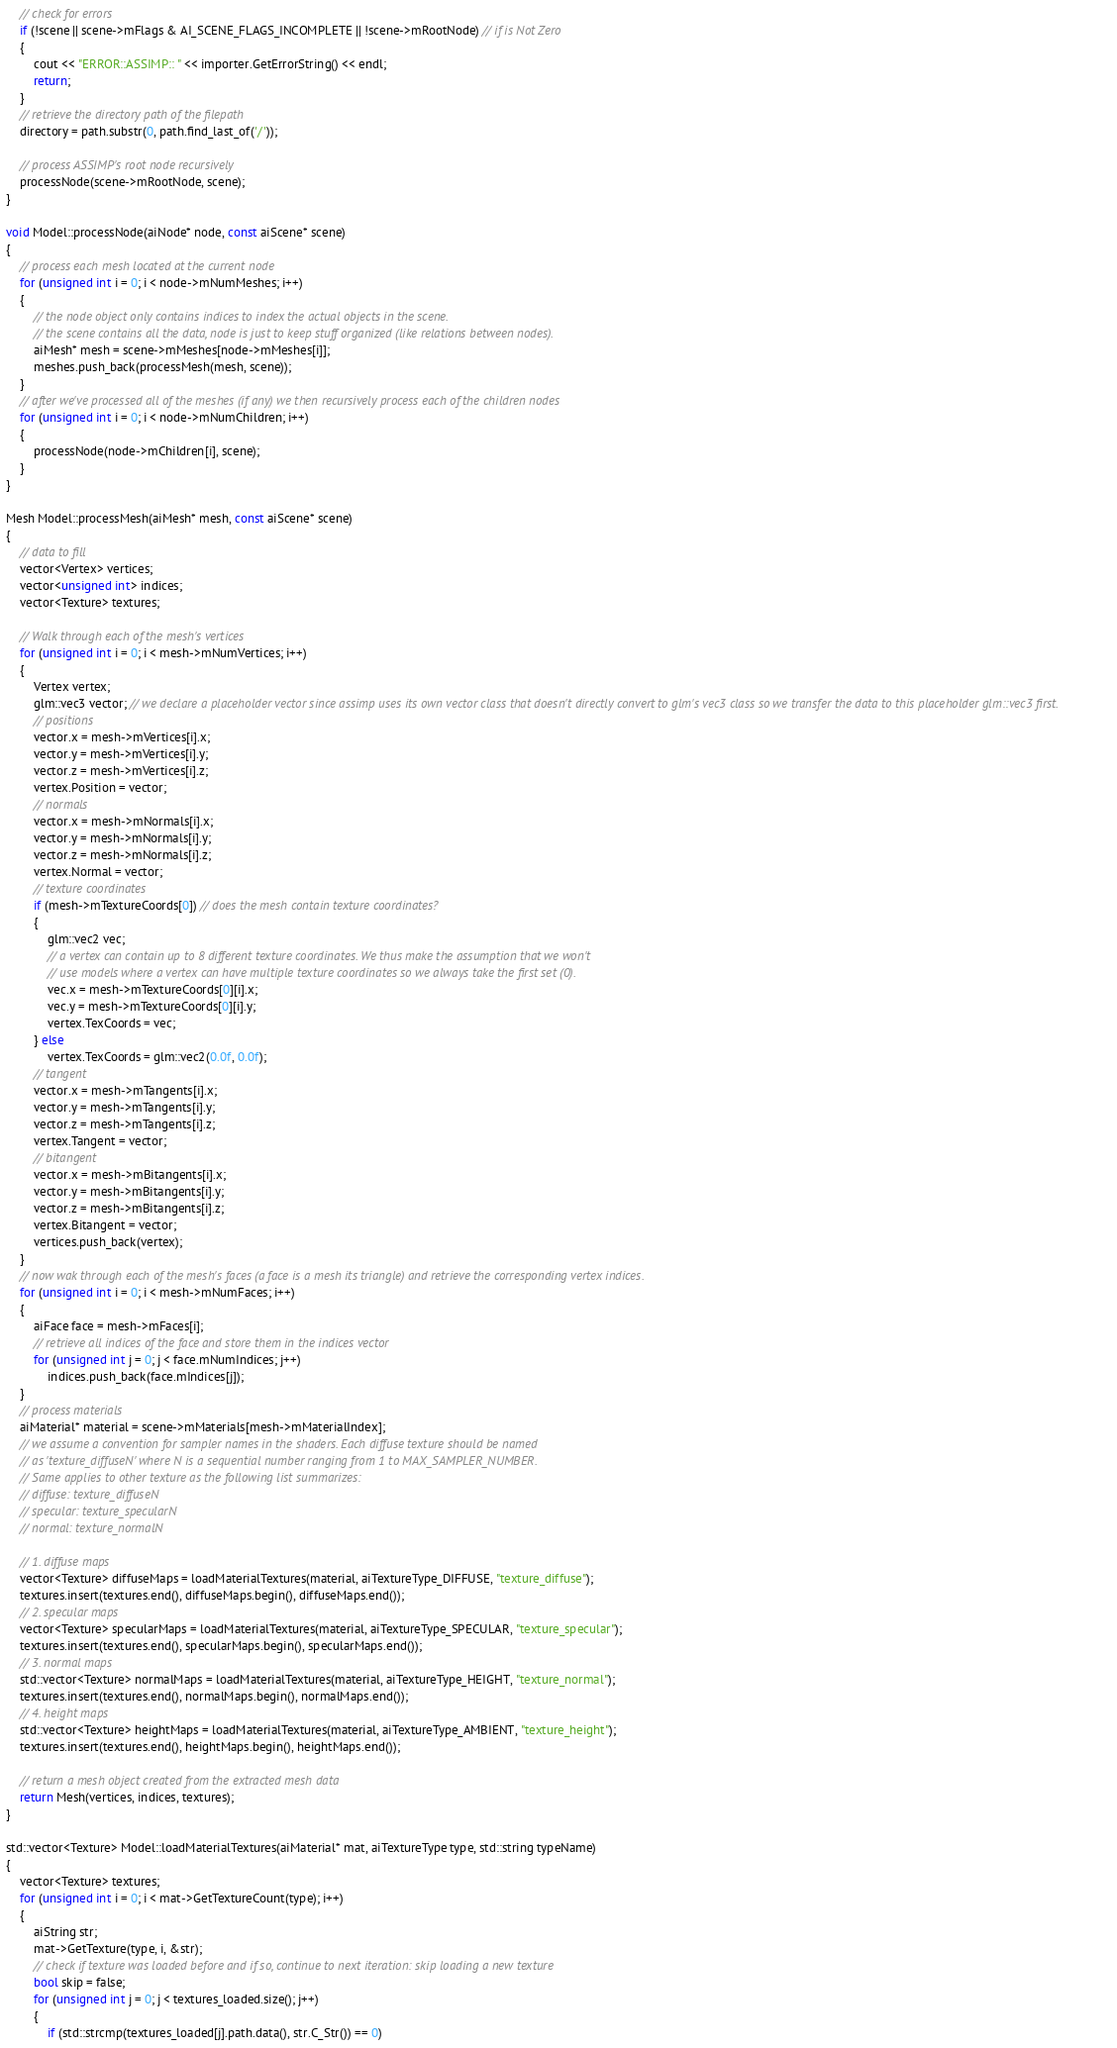<code> <loc_0><loc_0><loc_500><loc_500><_C++_>    // check for errors
    if (!scene || scene->mFlags & AI_SCENE_FLAGS_INCOMPLETE || !scene->mRootNode) // if is Not Zero
    {
        cout << "ERROR::ASSIMP:: " << importer.GetErrorString() << endl;
        return;
    }
    // retrieve the directory path of the filepath
    directory = path.substr(0, path.find_last_of('/'));

    // process ASSIMP's root node recursively
    processNode(scene->mRootNode, scene);
}

void Model::processNode(aiNode* node, const aiScene* scene)
{
    // process each mesh located at the current node
    for (unsigned int i = 0; i < node->mNumMeshes; i++)
    {
        // the node object only contains indices to index the actual objects in the scene. 
        // the scene contains all the data, node is just to keep stuff organized (like relations between nodes).
        aiMesh* mesh = scene->mMeshes[node->mMeshes[i]];
        meshes.push_back(processMesh(mesh, scene));
    }
    // after we've processed all of the meshes (if any) we then recursively process each of the children nodes
    for (unsigned int i = 0; i < node->mNumChildren; i++)
    {
        processNode(node->mChildren[i], scene);
    }
}

Mesh Model::processMesh(aiMesh* mesh, const aiScene* scene)
{
    // data to fill
    vector<Vertex> vertices;
    vector<unsigned int> indices;
    vector<Texture> textures;

    // Walk through each of the mesh's vertices
    for (unsigned int i = 0; i < mesh->mNumVertices; i++)
    {
        Vertex vertex;
        glm::vec3 vector; // we declare a placeholder vector since assimp uses its own vector class that doesn't directly convert to glm's vec3 class so we transfer the data to this placeholder glm::vec3 first.
        // positions
        vector.x = mesh->mVertices[i].x;
        vector.y = mesh->mVertices[i].y;
        vector.z = mesh->mVertices[i].z;
        vertex.Position = vector;
        // normals
        vector.x = mesh->mNormals[i].x;
        vector.y = mesh->mNormals[i].y;
        vector.z = mesh->mNormals[i].z;
        vertex.Normal = vector;
        // texture coordinates
        if (mesh->mTextureCoords[0]) // does the mesh contain texture coordinates?
        {
            glm::vec2 vec;
            // a vertex can contain up to 8 different texture coordinates. We thus make the assumption that we won't 
            // use models where a vertex can have multiple texture coordinates so we always take the first set (0).
            vec.x = mesh->mTextureCoords[0][i].x;
            vec.y = mesh->mTextureCoords[0][i].y;
            vertex.TexCoords = vec;
        } else
            vertex.TexCoords = glm::vec2(0.0f, 0.0f);
        // tangent
        vector.x = mesh->mTangents[i].x;
        vector.y = mesh->mTangents[i].y;
        vector.z = mesh->mTangents[i].z;
        vertex.Tangent = vector;
        // bitangent
        vector.x = mesh->mBitangents[i].x;
        vector.y = mesh->mBitangents[i].y;
        vector.z = mesh->mBitangents[i].z;
        vertex.Bitangent = vector;
        vertices.push_back(vertex);
    }
    // now wak through each of the mesh's faces (a face is a mesh its triangle) and retrieve the corresponding vertex indices.
    for (unsigned int i = 0; i < mesh->mNumFaces; i++)
    {
        aiFace face = mesh->mFaces[i];
        // retrieve all indices of the face and store them in the indices vector
        for (unsigned int j = 0; j < face.mNumIndices; j++)
            indices.push_back(face.mIndices[j]);
    }
    // process materials
    aiMaterial* material = scene->mMaterials[mesh->mMaterialIndex];
    // we assume a convention for sampler names in the shaders. Each diffuse texture should be named
    // as 'texture_diffuseN' where N is a sequential number ranging from 1 to MAX_SAMPLER_NUMBER. 
    // Same applies to other texture as the following list summarizes:
    // diffuse: texture_diffuseN
    // specular: texture_specularN
    // normal: texture_normalN

    // 1. diffuse maps
    vector<Texture> diffuseMaps = loadMaterialTextures(material, aiTextureType_DIFFUSE, "texture_diffuse");
    textures.insert(textures.end(), diffuseMaps.begin(), diffuseMaps.end());
    // 2. specular maps
    vector<Texture> specularMaps = loadMaterialTextures(material, aiTextureType_SPECULAR, "texture_specular");
    textures.insert(textures.end(), specularMaps.begin(), specularMaps.end());
    // 3. normal maps
    std::vector<Texture> normalMaps = loadMaterialTextures(material, aiTextureType_HEIGHT, "texture_normal");
    textures.insert(textures.end(), normalMaps.begin(), normalMaps.end());
    // 4. height maps
    std::vector<Texture> heightMaps = loadMaterialTextures(material, aiTextureType_AMBIENT, "texture_height");
    textures.insert(textures.end(), heightMaps.begin(), heightMaps.end());

    // return a mesh object created from the extracted mesh data
    return Mesh(vertices, indices, textures);
}

std::vector<Texture> Model::loadMaterialTextures(aiMaterial* mat, aiTextureType type, std::string typeName)
{
    vector<Texture> textures;
    for (unsigned int i = 0; i < mat->GetTextureCount(type); i++)
    {
        aiString str;
        mat->GetTexture(type, i, &str);
        // check if texture was loaded before and if so, continue to next iteration: skip loading a new texture
        bool skip = false;
        for (unsigned int j = 0; j < textures_loaded.size(); j++)
        {
            if (std::strcmp(textures_loaded[j].path.data(), str.C_Str()) == 0)</code> 